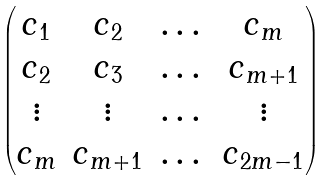Convert formula to latex. <formula><loc_0><loc_0><loc_500><loc_500>\begin{pmatrix} c _ { 1 } & c _ { 2 } & \dots & c _ { m } \\ c _ { 2 } & c _ { 3 } & \dots & c _ { m + 1 } \\ \vdots & \vdots & \dots & \vdots \\ c _ { m } & c _ { m + 1 } & \dots & c _ { 2 m - 1 } \end{pmatrix}</formula> 